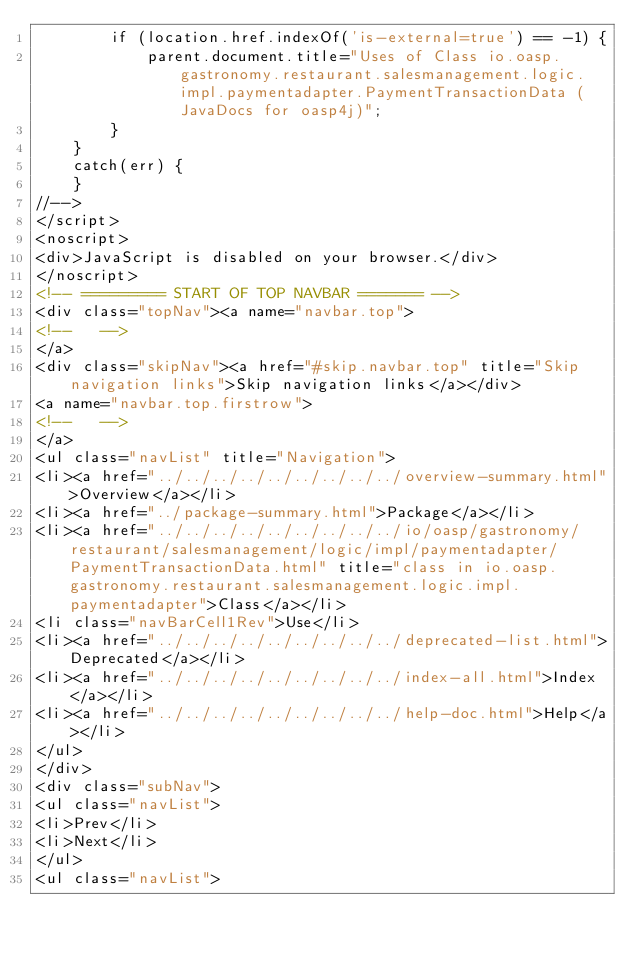<code> <loc_0><loc_0><loc_500><loc_500><_HTML_>        if (location.href.indexOf('is-external=true') == -1) {
            parent.document.title="Uses of Class io.oasp.gastronomy.restaurant.salesmanagement.logic.impl.paymentadapter.PaymentTransactionData (JavaDocs for oasp4j)";
        }
    }
    catch(err) {
    }
//-->
</script>
<noscript>
<div>JavaScript is disabled on your browser.</div>
</noscript>
<!-- ========= START OF TOP NAVBAR ======= -->
<div class="topNav"><a name="navbar.top">
<!--   -->
</a>
<div class="skipNav"><a href="#skip.navbar.top" title="Skip navigation links">Skip navigation links</a></div>
<a name="navbar.top.firstrow">
<!--   -->
</a>
<ul class="navList" title="Navigation">
<li><a href="../../../../../../../../../overview-summary.html">Overview</a></li>
<li><a href="../package-summary.html">Package</a></li>
<li><a href="../../../../../../../../../io/oasp/gastronomy/restaurant/salesmanagement/logic/impl/paymentadapter/PaymentTransactionData.html" title="class in io.oasp.gastronomy.restaurant.salesmanagement.logic.impl.paymentadapter">Class</a></li>
<li class="navBarCell1Rev">Use</li>
<li><a href="../../../../../../../../../deprecated-list.html">Deprecated</a></li>
<li><a href="../../../../../../../../../index-all.html">Index</a></li>
<li><a href="../../../../../../../../../help-doc.html">Help</a></li>
</ul>
</div>
<div class="subNav">
<ul class="navList">
<li>Prev</li>
<li>Next</li>
</ul>
<ul class="navList"></code> 